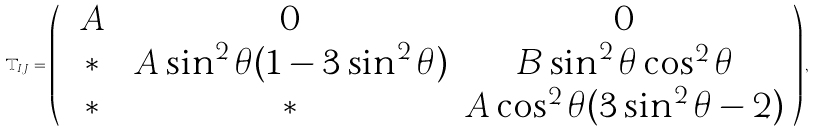Convert formula to latex. <formula><loc_0><loc_0><loc_500><loc_500>\mathbb { T } _ { I J } = \left ( \begin{array} { c c c } \ A \ & 0 & 0 \\ * & A \sin ^ { 2 } \theta ( 1 - 3 \sin ^ { 2 } \theta ) & B \sin ^ { 2 } \theta \cos ^ { 2 } \theta \\ * & * & A \cos ^ { 2 } \theta ( 3 \sin ^ { 2 } \theta - 2 ) \end{array} \right ) ,</formula> 